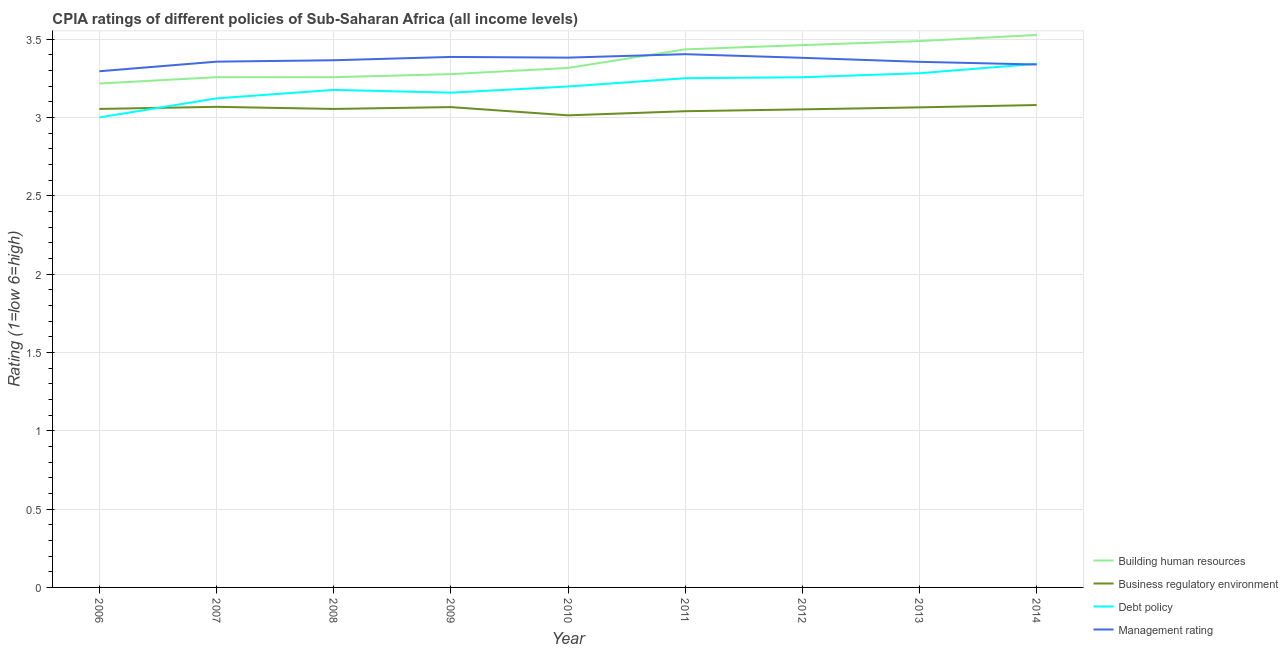Does the line corresponding to cpia rating of business regulatory environment intersect with the line corresponding to cpia rating of building human resources?
Ensure brevity in your answer.  No. Is the number of lines equal to the number of legend labels?
Your response must be concise. Yes. What is the cpia rating of management in 2010?
Provide a short and direct response. 3.38. Across all years, what is the maximum cpia rating of management?
Your answer should be compact. 3.4. Across all years, what is the minimum cpia rating of management?
Ensure brevity in your answer.  3.29. In which year was the cpia rating of management maximum?
Ensure brevity in your answer.  2011. What is the total cpia rating of business regulatory environment in the graph?
Make the answer very short. 27.49. What is the difference between the cpia rating of building human resources in 2010 and that in 2012?
Make the answer very short. -0.15. What is the difference between the cpia rating of business regulatory environment in 2006 and the cpia rating of debt policy in 2013?
Provide a short and direct response. -0.23. What is the average cpia rating of business regulatory environment per year?
Make the answer very short. 3.05. In the year 2010, what is the difference between the cpia rating of building human resources and cpia rating of business regulatory environment?
Offer a terse response. 0.3. What is the ratio of the cpia rating of management in 2012 to that in 2014?
Offer a very short reply. 1.01. What is the difference between the highest and the second highest cpia rating of business regulatory environment?
Make the answer very short. 0.01. What is the difference between the highest and the lowest cpia rating of building human resources?
Make the answer very short. 0.31. In how many years, is the cpia rating of building human resources greater than the average cpia rating of building human resources taken over all years?
Give a very brief answer. 4. Is it the case that in every year, the sum of the cpia rating of building human resources and cpia rating of business regulatory environment is greater than the cpia rating of debt policy?
Offer a terse response. Yes. Does the cpia rating of business regulatory environment monotonically increase over the years?
Make the answer very short. No. Is the cpia rating of building human resources strictly less than the cpia rating of management over the years?
Give a very brief answer. No. How many years are there in the graph?
Your answer should be very brief. 9. What is the difference between two consecutive major ticks on the Y-axis?
Your response must be concise. 0.5. Are the values on the major ticks of Y-axis written in scientific E-notation?
Offer a terse response. No. Does the graph contain any zero values?
Your response must be concise. No. Where does the legend appear in the graph?
Your answer should be compact. Bottom right. How many legend labels are there?
Offer a very short reply. 4. How are the legend labels stacked?
Provide a short and direct response. Vertical. What is the title of the graph?
Provide a succinct answer. CPIA ratings of different policies of Sub-Saharan Africa (all income levels). Does "UNDP" appear as one of the legend labels in the graph?
Your response must be concise. No. What is the Rating (1=low 6=high) in Building human resources in 2006?
Give a very brief answer. 3.22. What is the Rating (1=low 6=high) in Business regulatory environment in 2006?
Provide a succinct answer. 3.05. What is the Rating (1=low 6=high) in Debt policy in 2006?
Provide a short and direct response. 3. What is the Rating (1=low 6=high) of Management rating in 2006?
Make the answer very short. 3.29. What is the Rating (1=low 6=high) of Building human resources in 2007?
Your answer should be compact. 3.26. What is the Rating (1=low 6=high) in Business regulatory environment in 2007?
Your response must be concise. 3.07. What is the Rating (1=low 6=high) of Debt policy in 2007?
Provide a short and direct response. 3.12. What is the Rating (1=low 6=high) of Management rating in 2007?
Provide a succinct answer. 3.36. What is the Rating (1=low 6=high) of Building human resources in 2008?
Keep it short and to the point. 3.26. What is the Rating (1=low 6=high) in Business regulatory environment in 2008?
Ensure brevity in your answer.  3.05. What is the Rating (1=low 6=high) in Debt policy in 2008?
Make the answer very short. 3.18. What is the Rating (1=low 6=high) of Management rating in 2008?
Keep it short and to the point. 3.36. What is the Rating (1=low 6=high) of Building human resources in 2009?
Your answer should be compact. 3.28. What is the Rating (1=low 6=high) in Business regulatory environment in 2009?
Ensure brevity in your answer.  3.07. What is the Rating (1=low 6=high) in Debt policy in 2009?
Ensure brevity in your answer.  3.16. What is the Rating (1=low 6=high) of Management rating in 2009?
Your response must be concise. 3.39. What is the Rating (1=low 6=high) in Building human resources in 2010?
Your answer should be compact. 3.32. What is the Rating (1=low 6=high) of Business regulatory environment in 2010?
Offer a terse response. 3.01. What is the Rating (1=low 6=high) of Debt policy in 2010?
Keep it short and to the point. 3.2. What is the Rating (1=low 6=high) of Management rating in 2010?
Ensure brevity in your answer.  3.38. What is the Rating (1=low 6=high) in Building human resources in 2011?
Provide a short and direct response. 3.43. What is the Rating (1=low 6=high) of Business regulatory environment in 2011?
Your answer should be compact. 3.04. What is the Rating (1=low 6=high) in Management rating in 2011?
Ensure brevity in your answer.  3.4. What is the Rating (1=low 6=high) of Building human resources in 2012?
Provide a short and direct response. 3.46. What is the Rating (1=low 6=high) of Business regulatory environment in 2012?
Your answer should be compact. 3.05. What is the Rating (1=low 6=high) of Debt policy in 2012?
Your answer should be compact. 3.26. What is the Rating (1=low 6=high) in Management rating in 2012?
Ensure brevity in your answer.  3.38. What is the Rating (1=low 6=high) of Building human resources in 2013?
Provide a short and direct response. 3.49. What is the Rating (1=low 6=high) of Business regulatory environment in 2013?
Keep it short and to the point. 3.06. What is the Rating (1=low 6=high) in Debt policy in 2013?
Offer a very short reply. 3.28. What is the Rating (1=low 6=high) of Management rating in 2013?
Make the answer very short. 3.35. What is the Rating (1=low 6=high) of Building human resources in 2014?
Your answer should be very brief. 3.53. What is the Rating (1=low 6=high) of Business regulatory environment in 2014?
Your answer should be very brief. 3.08. What is the Rating (1=low 6=high) of Debt policy in 2014?
Give a very brief answer. 3.34. What is the Rating (1=low 6=high) in Management rating in 2014?
Provide a short and direct response. 3.34. Across all years, what is the maximum Rating (1=low 6=high) of Building human resources?
Offer a very short reply. 3.53. Across all years, what is the maximum Rating (1=low 6=high) in Business regulatory environment?
Make the answer very short. 3.08. Across all years, what is the maximum Rating (1=low 6=high) of Debt policy?
Give a very brief answer. 3.34. Across all years, what is the maximum Rating (1=low 6=high) of Management rating?
Your response must be concise. 3.4. Across all years, what is the minimum Rating (1=low 6=high) of Building human resources?
Make the answer very short. 3.22. Across all years, what is the minimum Rating (1=low 6=high) of Business regulatory environment?
Provide a short and direct response. 3.01. Across all years, what is the minimum Rating (1=low 6=high) in Debt policy?
Provide a short and direct response. 3. Across all years, what is the minimum Rating (1=low 6=high) of Management rating?
Your answer should be very brief. 3.29. What is the total Rating (1=low 6=high) of Building human resources in the graph?
Keep it short and to the point. 30.23. What is the total Rating (1=low 6=high) of Business regulatory environment in the graph?
Your response must be concise. 27.49. What is the total Rating (1=low 6=high) of Debt policy in the graph?
Make the answer very short. 28.78. What is the total Rating (1=low 6=high) of Management rating in the graph?
Your answer should be compact. 30.26. What is the difference between the Rating (1=low 6=high) of Building human resources in 2006 and that in 2007?
Give a very brief answer. -0.04. What is the difference between the Rating (1=low 6=high) of Business regulatory environment in 2006 and that in 2007?
Offer a very short reply. -0.01. What is the difference between the Rating (1=low 6=high) of Debt policy in 2006 and that in 2007?
Your response must be concise. -0.12. What is the difference between the Rating (1=low 6=high) of Management rating in 2006 and that in 2007?
Your response must be concise. -0.06. What is the difference between the Rating (1=low 6=high) in Building human resources in 2006 and that in 2008?
Give a very brief answer. -0.04. What is the difference between the Rating (1=low 6=high) of Debt policy in 2006 and that in 2008?
Make the answer very short. -0.18. What is the difference between the Rating (1=low 6=high) of Management rating in 2006 and that in 2008?
Offer a very short reply. -0.07. What is the difference between the Rating (1=low 6=high) in Building human resources in 2006 and that in 2009?
Give a very brief answer. -0.06. What is the difference between the Rating (1=low 6=high) of Business regulatory environment in 2006 and that in 2009?
Offer a terse response. -0.01. What is the difference between the Rating (1=low 6=high) of Debt policy in 2006 and that in 2009?
Provide a succinct answer. -0.16. What is the difference between the Rating (1=low 6=high) in Management rating in 2006 and that in 2009?
Make the answer very short. -0.09. What is the difference between the Rating (1=low 6=high) in Building human resources in 2006 and that in 2010?
Make the answer very short. -0.1. What is the difference between the Rating (1=low 6=high) of Business regulatory environment in 2006 and that in 2010?
Make the answer very short. 0.04. What is the difference between the Rating (1=low 6=high) of Debt policy in 2006 and that in 2010?
Offer a terse response. -0.2. What is the difference between the Rating (1=low 6=high) of Management rating in 2006 and that in 2010?
Give a very brief answer. -0.09. What is the difference between the Rating (1=low 6=high) in Building human resources in 2006 and that in 2011?
Make the answer very short. -0.22. What is the difference between the Rating (1=low 6=high) of Business regulatory environment in 2006 and that in 2011?
Provide a succinct answer. 0.01. What is the difference between the Rating (1=low 6=high) in Management rating in 2006 and that in 2011?
Your answer should be very brief. -0.11. What is the difference between the Rating (1=low 6=high) of Building human resources in 2006 and that in 2012?
Provide a succinct answer. -0.25. What is the difference between the Rating (1=low 6=high) of Business regulatory environment in 2006 and that in 2012?
Keep it short and to the point. 0. What is the difference between the Rating (1=low 6=high) of Debt policy in 2006 and that in 2012?
Offer a terse response. -0.26. What is the difference between the Rating (1=low 6=high) of Management rating in 2006 and that in 2012?
Keep it short and to the point. -0.09. What is the difference between the Rating (1=low 6=high) in Building human resources in 2006 and that in 2013?
Make the answer very short. -0.27. What is the difference between the Rating (1=low 6=high) in Business regulatory environment in 2006 and that in 2013?
Make the answer very short. -0.01. What is the difference between the Rating (1=low 6=high) of Debt policy in 2006 and that in 2013?
Offer a terse response. -0.28. What is the difference between the Rating (1=low 6=high) of Management rating in 2006 and that in 2013?
Give a very brief answer. -0.06. What is the difference between the Rating (1=low 6=high) in Building human resources in 2006 and that in 2014?
Ensure brevity in your answer.  -0.31. What is the difference between the Rating (1=low 6=high) in Business regulatory environment in 2006 and that in 2014?
Offer a very short reply. -0.02. What is the difference between the Rating (1=low 6=high) of Debt policy in 2006 and that in 2014?
Your answer should be very brief. -0.34. What is the difference between the Rating (1=low 6=high) of Management rating in 2006 and that in 2014?
Offer a terse response. -0.04. What is the difference between the Rating (1=low 6=high) of Building human resources in 2007 and that in 2008?
Provide a short and direct response. 0. What is the difference between the Rating (1=low 6=high) of Business regulatory environment in 2007 and that in 2008?
Offer a terse response. 0.01. What is the difference between the Rating (1=low 6=high) of Debt policy in 2007 and that in 2008?
Keep it short and to the point. -0.05. What is the difference between the Rating (1=low 6=high) of Management rating in 2007 and that in 2008?
Offer a terse response. -0.01. What is the difference between the Rating (1=low 6=high) of Building human resources in 2007 and that in 2009?
Your answer should be very brief. -0.02. What is the difference between the Rating (1=low 6=high) in Business regulatory environment in 2007 and that in 2009?
Offer a terse response. 0. What is the difference between the Rating (1=low 6=high) in Debt policy in 2007 and that in 2009?
Provide a short and direct response. -0.04. What is the difference between the Rating (1=low 6=high) of Management rating in 2007 and that in 2009?
Give a very brief answer. -0.03. What is the difference between the Rating (1=low 6=high) of Building human resources in 2007 and that in 2010?
Make the answer very short. -0.06. What is the difference between the Rating (1=low 6=high) of Business regulatory environment in 2007 and that in 2010?
Provide a succinct answer. 0.05. What is the difference between the Rating (1=low 6=high) of Debt policy in 2007 and that in 2010?
Your response must be concise. -0.08. What is the difference between the Rating (1=low 6=high) in Management rating in 2007 and that in 2010?
Give a very brief answer. -0.03. What is the difference between the Rating (1=low 6=high) of Building human resources in 2007 and that in 2011?
Provide a short and direct response. -0.18. What is the difference between the Rating (1=low 6=high) of Business regulatory environment in 2007 and that in 2011?
Keep it short and to the point. 0.03. What is the difference between the Rating (1=low 6=high) of Debt policy in 2007 and that in 2011?
Provide a succinct answer. -0.13. What is the difference between the Rating (1=low 6=high) in Management rating in 2007 and that in 2011?
Your response must be concise. -0.05. What is the difference between the Rating (1=low 6=high) of Building human resources in 2007 and that in 2012?
Provide a succinct answer. -0.2. What is the difference between the Rating (1=low 6=high) of Business regulatory environment in 2007 and that in 2012?
Your response must be concise. 0.02. What is the difference between the Rating (1=low 6=high) of Debt policy in 2007 and that in 2012?
Offer a terse response. -0.13. What is the difference between the Rating (1=low 6=high) of Management rating in 2007 and that in 2012?
Offer a terse response. -0.02. What is the difference between the Rating (1=low 6=high) of Building human resources in 2007 and that in 2013?
Give a very brief answer. -0.23. What is the difference between the Rating (1=low 6=high) in Business regulatory environment in 2007 and that in 2013?
Provide a short and direct response. 0. What is the difference between the Rating (1=low 6=high) of Debt policy in 2007 and that in 2013?
Keep it short and to the point. -0.16. What is the difference between the Rating (1=low 6=high) in Management rating in 2007 and that in 2013?
Your answer should be very brief. 0. What is the difference between the Rating (1=low 6=high) in Building human resources in 2007 and that in 2014?
Ensure brevity in your answer.  -0.27. What is the difference between the Rating (1=low 6=high) of Business regulatory environment in 2007 and that in 2014?
Provide a succinct answer. -0.01. What is the difference between the Rating (1=low 6=high) in Debt policy in 2007 and that in 2014?
Your answer should be compact. -0.22. What is the difference between the Rating (1=low 6=high) in Management rating in 2007 and that in 2014?
Give a very brief answer. 0.02. What is the difference between the Rating (1=low 6=high) of Building human resources in 2008 and that in 2009?
Ensure brevity in your answer.  -0.02. What is the difference between the Rating (1=low 6=high) of Business regulatory environment in 2008 and that in 2009?
Provide a short and direct response. -0.01. What is the difference between the Rating (1=low 6=high) of Debt policy in 2008 and that in 2009?
Ensure brevity in your answer.  0.02. What is the difference between the Rating (1=low 6=high) of Management rating in 2008 and that in 2009?
Provide a succinct answer. -0.02. What is the difference between the Rating (1=low 6=high) in Building human resources in 2008 and that in 2010?
Provide a succinct answer. -0.06. What is the difference between the Rating (1=low 6=high) in Business regulatory environment in 2008 and that in 2010?
Offer a terse response. 0.04. What is the difference between the Rating (1=low 6=high) of Debt policy in 2008 and that in 2010?
Offer a very short reply. -0.02. What is the difference between the Rating (1=low 6=high) in Management rating in 2008 and that in 2010?
Provide a short and direct response. -0.02. What is the difference between the Rating (1=low 6=high) of Building human resources in 2008 and that in 2011?
Make the answer very short. -0.18. What is the difference between the Rating (1=low 6=high) of Business regulatory environment in 2008 and that in 2011?
Provide a short and direct response. 0.01. What is the difference between the Rating (1=low 6=high) in Debt policy in 2008 and that in 2011?
Your response must be concise. -0.07. What is the difference between the Rating (1=low 6=high) of Management rating in 2008 and that in 2011?
Give a very brief answer. -0.04. What is the difference between the Rating (1=low 6=high) of Building human resources in 2008 and that in 2012?
Offer a very short reply. -0.2. What is the difference between the Rating (1=low 6=high) of Business regulatory environment in 2008 and that in 2012?
Offer a very short reply. 0. What is the difference between the Rating (1=low 6=high) in Debt policy in 2008 and that in 2012?
Your answer should be very brief. -0.08. What is the difference between the Rating (1=low 6=high) of Management rating in 2008 and that in 2012?
Provide a succinct answer. -0.02. What is the difference between the Rating (1=low 6=high) in Building human resources in 2008 and that in 2013?
Your answer should be very brief. -0.23. What is the difference between the Rating (1=low 6=high) of Business regulatory environment in 2008 and that in 2013?
Make the answer very short. -0.01. What is the difference between the Rating (1=low 6=high) in Debt policy in 2008 and that in 2013?
Offer a very short reply. -0.11. What is the difference between the Rating (1=low 6=high) of Management rating in 2008 and that in 2013?
Give a very brief answer. 0.01. What is the difference between the Rating (1=low 6=high) in Building human resources in 2008 and that in 2014?
Ensure brevity in your answer.  -0.27. What is the difference between the Rating (1=low 6=high) of Business regulatory environment in 2008 and that in 2014?
Ensure brevity in your answer.  -0.02. What is the difference between the Rating (1=low 6=high) in Debt policy in 2008 and that in 2014?
Offer a terse response. -0.17. What is the difference between the Rating (1=low 6=high) in Management rating in 2008 and that in 2014?
Keep it short and to the point. 0.03. What is the difference between the Rating (1=low 6=high) of Building human resources in 2009 and that in 2010?
Your answer should be compact. -0.04. What is the difference between the Rating (1=low 6=high) of Business regulatory environment in 2009 and that in 2010?
Your answer should be very brief. 0.05. What is the difference between the Rating (1=low 6=high) of Debt policy in 2009 and that in 2010?
Ensure brevity in your answer.  -0.04. What is the difference between the Rating (1=low 6=high) of Management rating in 2009 and that in 2010?
Your response must be concise. 0. What is the difference between the Rating (1=low 6=high) in Building human resources in 2009 and that in 2011?
Ensure brevity in your answer.  -0.16. What is the difference between the Rating (1=low 6=high) in Business regulatory environment in 2009 and that in 2011?
Provide a short and direct response. 0.03. What is the difference between the Rating (1=low 6=high) in Debt policy in 2009 and that in 2011?
Ensure brevity in your answer.  -0.09. What is the difference between the Rating (1=low 6=high) in Management rating in 2009 and that in 2011?
Provide a succinct answer. -0.02. What is the difference between the Rating (1=low 6=high) in Building human resources in 2009 and that in 2012?
Your answer should be compact. -0.19. What is the difference between the Rating (1=low 6=high) in Business regulatory environment in 2009 and that in 2012?
Give a very brief answer. 0.01. What is the difference between the Rating (1=low 6=high) in Debt policy in 2009 and that in 2012?
Offer a terse response. -0.1. What is the difference between the Rating (1=low 6=high) of Management rating in 2009 and that in 2012?
Offer a very short reply. 0.01. What is the difference between the Rating (1=low 6=high) in Building human resources in 2009 and that in 2013?
Your answer should be compact. -0.21. What is the difference between the Rating (1=low 6=high) in Business regulatory environment in 2009 and that in 2013?
Offer a very short reply. 0. What is the difference between the Rating (1=low 6=high) of Debt policy in 2009 and that in 2013?
Offer a terse response. -0.12. What is the difference between the Rating (1=low 6=high) in Management rating in 2009 and that in 2013?
Provide a short and direct response. 0.03. What is the difference between the Rating (1=low 6=high) of Business regulatory environment in 2009 and that in 2014?
Ensure brevity in your answer.  -0.01. What is the difference between the Rating (1=low 6=high) of Debt policy in 2009 and that in 2014?
Give a very brief answer. -0.18. What is the difference between the Rating (1=low 6=high) of Management rating in 2009 and that in 2014?
Provide a succinct answer. 0.05. What is the difference between the Rating (1=low 6=high) of Building human resources in 2010 and that in 2011?
Provide a succinct answer. -0.12. What is the difference between the Rating (1=low 6=high) of Business regulatory environment in 2010 and that in 2011?
Your answer should be very brief. -0.03. What is the difference between the Rating (1=low 6=high) in Debt policy in 2010 and that in 2011?
Ensure brevity in your answer.  -0.05. What is the difference between the Rating (1=low 6=high) of Management rating in 2010 and that in 2011?
Offer a terse response. -0.02. What is the difference between the Rating (1=low 6=high) in Building human resources in 2010 and that in 2012?
Keep it short and to the point. -0.15. What is the difference between the Rating (1=low 6=high) of Business regulatory environment in 2010 and that in 2012?
Offer a very short reply. -0.04. What is the difference between the Rating (1=low 6=high) in Debt policy in 2010 and that in 2012?
Keep it short and to the point. -0.06. What is the difference between the Rating (1=low 6=high) of Management rating in 2010 and that in 2012?
Give a very brief answer. 0. What is the difference between the Rating (1=low 6=high) of Building human resources in 2010 and that in 2013?
Offer a terse response. -0.17. What is the difference between the Rating (1=low 6=high) in Business regulatory environment in 2010 and that in 2013?
Give a very brief answer. -0.05. What is the difference between the Rating (1=low 6=high) of Debt policy in 2010 and that in 2013?
Your answer should be compact. -0.08. What is the difference between the Rating (1=low 6=high) in Management rating in 2010 and that in 2013?
Provide a succinct answer. 0.03. What is the difference between the Rating (1=low 6=high) in Building human resources in 2010 and that in 2014?
Provide a succinct answer. -0.21. What is the difference between the Rating (1=low 6=high) of Business regulatory environment in 2010 and that in 2014?
Your answer should be very brief. -0.07. What is the difference between the Rating (1=low 6=high) in Debt policy in 2010 and that in 2014?
Offer a very short reply. -0.14. What is the difference between the Rating (1=low 6=high) of Management rating in 2010 and that in 2014?
Give a very brief answer. 0.04. What is the difference between the Rating (1=low 6=high) of Building human resources in 2011 and that in 2012?
Give a very brief answer. -0.03. What is the difference between the Rating (1=low 6=high) in Business regulatory environment in 2011 and that in 2012?
Ensure brevity in your answer.  -0.01. What is the difference between the Rating (1=low 6=high) of Debt policy in 2011 and that in 2012?
Your answer should be very brief. -0.01. What is the difference between the Rating (1=low 6=high) of Management rating in 2011 and that in 2012?
Your answer should be very brief. 0.02. What is the difference between the Rating (1=low 6=high) in Building human resources in 2011 and that in 2013?
Offer a very short reply. -0.05. What is the difference between the Rating (1=low 6=high) of Business regulatory environment in 2011 and that in 2013?
Ensure brevity in your answer.  -0.02. What is the difference between the Rating (1=low 6=high) of Debt policy in 2011 and that in 2013?
Offer a terse response. -0.03. What is the difference between the Rating (1=low 6=high) of Management rating in 2011 and that in 2013?
Make the answer very short. 0.05. What is the difference between the Rating (1=low 6=high) in Building human resources in 2011 and that in 2014?
Offer a terse response. -0.09. What is the difference between the Rating (1=low 6=high) of Business regulatory environment in 2011 and that in 2014?
Provide a succinct answer. -0.04. What is the difference between the Rating (1=low 6=high) of Debt policy in 2011 and that in 2014?
Give a very brief answer. -0.09. What is the difference between the Rating (1=low 6=high) in Management rating in 2011 and that in 2014?
Your response must be concise. 0.07. What is the difference between the Rating (1=low 6=high) in Building human resources in 2012 and that in 2013?
Your answer should be very brief. -0.03. What is the difference between the Rating (1=low 6=high) of Business regulatory environment in 2012 and that in 2013?
Offer a very short reply. -0.01. What is the difference between the Rating (1=low 6=high) of Debt policy in 2012 and that in 2013?
Keep it short and to the point. -0.03. What is the difference between the Rating (1=low 6=high) of Management rating in 2012 and that in 2013?
Offer a terse response. 0.03. What is the difference between the Rating (1=low 6=high) of Building human resources in 2012 and that in 2014?
Provide a short and direct response. -0.06. What is the difference between the Rating (1=low 6=high) in Business regulatory environment in 2012 and that in 2014?
Provide a succinct answer. -0.03. What is the difference between the Rating (1=low 6=high) in Debt policy in 2012 and that in 2014?
Keep it short and to the point. -0.09. What is the difference between the Rating (1=low 6=high) of Management rating in 2012 and that in 2014?
Your answer should be very brief. 0.04. What is the difference between the Rating (1=low 6=high) of Building human resources in 2013 and that in 2014?
Give a very brief answer. -0.04. What is the difference between the Rating (1=low 6=high) of Business regulatory environment in 2013 and that in 2014?
Your response must be concise. -0.01. What is the difference between the Rating (1=low 6=high) in Debt policy in 2013 and that in 2014?
Provide a short and direct response. -0.06. What is the difference between the Rating (1=low 6=high) in Management rating in 2013 and that in 2014?
Your answer should be very brief. 0.02. What is the difference between the Rating (1=low 6=high) in Building human resources in 2006 and the Rating (1=low 6=high) in Business regulatory environment in 2007?
Provide a short and direct response. 0.15. What is the difference between the Rating (1=low 6=high) in Building human resources in 2006 and the Rating (1=low 6=high) in Debt policy in 2007?
Keep it short and to the point. 0.09. What is the difference between the Rating (1=low 6=high) of Building human resources in 2006 and the Rating (1=low 6=high) of Management rating in 2007?
Provide a succinct answer. -0.14. What is the difference between the Rating (1=low 6=high) in Business regulatory environment in 2006 and the Rating (1=low 6=high) in Debt policy in 2007?
Your response must be concise. -0.07. What is the difference between the Rating (1=low 6=high) of Business regulatory environment in 2006 and the Rating (1=low 6=high) of Management rating in 2007?
Ensure brevity in your answer.  -0.3. What is the difference between the Rating (1=low 6=high) of Debt policy in 2006 and the Rating (1=low 6=high) of Management rating in 2007?
Keep it short and to the point. -0.36. What is the difference between the Rating (1=low 6=high) of Building human resources in 2006 and the Rating (1=low 6=high) of Business regulatory environment in 2008?
Offer a terse response. 0.16. What is the difference between the Rating (1=low 6=high) in Building human resources in 2006 and the Rating (1=low 6=high) in Debt policy in 2008?
Your answer should be very brief. 0.04. What is the difference between the Rating (1=low 6=high) of Building human resources in 2006 and the Rating (1=low 6=high) of Management rating in 2008?
Your answer should be compact. -0.15. What is the difference between the Rating (1=low 6=high) of Business regulatory environment in 2006 and the Rating (1=low 6=high) of Debt policy in 2008?
Keep it short and to the point. -0.12. What is the difference between the Rating (1=low 6=high) of Business regulatory environment in 2006 and the Rating (1=low 6=high) of Management rating in 2008?
Keep it short and to the point. -0.31. What is the difference between the Rating (1=low 6=high) of Debt policy in 2006 and the Rating (1=low 6=high) of Management rating in 2008?
Provide a succinct answer. -0.36. What is the difference between the Rating (1=low 6=high) in Building human resources in 2006 and the Rating (1=low 6=high) in Business regulatory environment in 2009?
Keep it short and to the point. 0.15. What is the difference between the Rating (1=low 6=high) in Building human resources in 2006 and the Rating (1=low 6=high) in Debt policy in 2009?
Your answer should be very brief. 0.06. What is the difference between the Rating (1=low 6=high) of Building human resources in 2006 and the Rating (1=low 6=high) of Management rating in 2009?
Provide a succinct answer. -0.17. What is the difference between the Rating (1=low 6=high) in Business regulatory environment in 2006 and the Rating (1=low 6=high) in Debt policy in 2009?
Provide a succinct answer. -0.1. What is the difference between the Rating (1=low 6=high) in Business regulatory environment in 2006 and the Rating (1=low 6=high) in Management rating in 2009?
Give a very brief answer. -0.33. What is the difference between the Rating (1=low 6=high) of Debt policy in 2006 and the Rating (1=low 6=high) of Management rating in 2009?
Give a very brief answer. -0.39. What is the difference between the Rating (1=low 6=high) in Building human resources in 2006 and the Rating (1=low 6=high) in Business regulatory environment in 2010?
Your answer should be very brief. 0.2. What is the difference between the Rating (1=low 6=high) of Building human resources in 2006 and the Rating (1=low 6=high) of Debt policy in 2010?
Your answer should be very brief. 0.02. What is the difference between the Rating (1=low 6=high) of Building human resources in 2006 and the Rating (1=low 6=high) of Management rating in 2010?
Provide a succinct answer. -0.17. What is the difference between the Rating (1=low 6=high) in Business regulatory environment in 2006 and the Rating (1=low 6=high) in Debt policy in 2010?
Ensure brevity in your answer.  -0.14. What is the difference between the Rating (1=low 6=high) of Business regulatory environment in 2006 and the Rating (1=low 6=high) of Management rating in 2010?
Offer a very short reply. -0.33. What is the difference between the Rating (1=low 6=high) in Debt policy in 2006 and the Rating (1=low 6=high) in Management rating in 2010?
Give a very brief answer. -0.38. What is the difference between the Rating (1=low 6=high) in Building human resources in 2006 and the Rating (1=low 6=high) in Business regulatory environment in 2011?
Provide a succinct answer. 0.18. What is the difference between the Rating (1=low 6=high) of Building human resources in 2006 and the Rating (1=low 6=high) of Debt policy in 2011?
Provide a succinct answer. -0.03. What is the difference between the Rating (1=low 6=high) in Building human resources in 2006 and the Rating (1=low 6=high) in Management rating in 2011?
Your answer should be compact. -0.19. What is the difference between the Rating (1=low 6=high) in Business regulatory environment in 2006 and the Rating (1=low 6=high) in Debt policy in 2011?
Provide a short and direct response. -0.2. What is the difference between the Rating (1=low 6=high) of Business regulatory environment in 2006 and the Rating (1=low 6=high) of Management rating in 2011?
Keep it short and to the point. -0.35. What is the difference between the Rating (1=low 6=high) in Debt policy in 2006 and the Rating (1=low 6=high) in Management rating in 2011?
Make the answer very short. -0.4. What is the difference between the Rating (1=low 6=high) in Building human resources in 2006 and the Rating (1=low 6=high) in Business regulatory environment in 2012?
Your answer should be compact. 0.16. What is the difference between the Rating (1=low 6=high) in Building human resources in 2006 and the Rating (1=low 6=high) in Debt policy in 2012?
Offer a very short reply. -0.04. What is the difference between the Rating (1=low 6=high) in Building human resources in 2006 and the Rating (1=low 6=high) in Management rating in 2012?
Provide a short and direct response. -0.16. What is the difference between the Rating (1=low 6=high) of Business regulatory environment in 2006 and the Rating (1=low 6=high) of Debt policy in 2012?
Give a very brief answer. -0.2. What is the difference between the Rating (1=low 6=high) of Business regulatory environment in 2006 and the Rating (1=low 6=high) of Management rating in 2012?
Your response must be concise. -0.33. What is the difference between the Rating (1=low 6=high) of Debt policy in 2006 and the Rating (1=low 6=high) of Management rating in 2012?
Ensure brevity in your answer.  -0.38. What is the difference between the Rating (1=low 6=high) in Building human resources in 2006 and the Rating (1=low 6=high) in Business regulatory environment in 2013?
Provide a succinct answer. 0.15. What is the difference between the Rating (1=low 6=high) of Building human resources in 2006 and the Rating (1=low 6=high) of Debt policy in 2013?
Provide a succinct answer. -0.07. What is the difference between the Rating (1=low 6=high) of Building human resources in 2006 and the Rating (1=low 6=high) of Management rating in 2013?
Give a very brief answer. -0.14. What is the difference between the Rating (1=low 6=high) in Business regulatory environment in 2006 and the Rating (1=low 6=high) in Debt policy in 2013?
Your answer should be very brief. -0.23. What is the difference between the Rating (1=low 6=high) in Business regulatory environment in 2006 and the Rating (1=low 6=high) in Management rating in 2013?
Provide a short and direct response. -0.3. What is the difference between the Rating (1=low 6=high) in Debt policy in 2006 and the Rating (1=low 6=high) in Management rating in 2013?
Offer a very short reply. -0.35. What is the difference between the Rating (1=low 6=high) in Building human resources in 2006 and the Rating (1=low 6=high) in Business regulatory environment in 2014?
Your response must be concise. 0.14. What is the difference between the Rating (1=low 6=high) of Building human resources in 2006 and the Rating (1=low 6=high) of Debt policy in 2014?
Give a very brief answer. -0.13. What is the difference between the Rating (1=low 6=high) in Building human resources in 2006 and the Rating (1=low 6=high) in Management rating in 2014?
Give a very brief answer. -0.12. What is the difference between the Rating (1=low 6=high) in Business regulatory environment in 2006 and the Rating (1=low 6=high) in Debt policy in 2014?
Your response must be concise. -0.29. What is the difference between the Rating (1=low 6=high) of Business regulatory environment in 2006 and the Rating (1=low 6=high) of Management rating in 2014?
Offer a very short reply. -0.28. What is the difference between the Rating (1=low 6=high) of Debt policy in 2006 and the Rating (1=low 6=high) of Management rating in 2014?
Your answer should be very brief. -0.34. What is the difference between the Rating (1=low 6=high) in Building human resources in 2007 and the Rating (1=low 6=high) in Business regulatory environment in 2008?
Your response must be concise. 0.2. What is the difference between the Rating (1=low 6=high) in Building human resources in 2007 and the Rating (1=low 6=high) in Debt policy in 2008?
Your response must be concise. 0.08. What is the difference between the Rating (1=low 6=high) in Building human resources in 2007 and the Rating (1=low 6=high) in Management rating in 2008?
Give a very brief answer. -0.11. What is the difference between the Rating (1=low 6=high) in Business regulatory environment in 2007 and the Rating (1=low 6=high) in Debt policy in 2008?
Your response must be concise. -0.11. What is the difference between the Rating (1=low 6=high) of Business regulatory environment in 2007 and the Rating (1=low 6=high) of Management rating in 2008?
Your answer should be very brief. -0.3. What is the difference between the Rating (1=low 6=high) in Debt policy in 2007 and the Rating (1=low 6=high) in Management rating in 2008?
Offer a very short reply. -0.24. What is the difference between the Rating (1=low 6=high) in Building human resources in 2007 and the Rating (1=low 6=high) in Business regulatory environment in 2009?
Your answer should be very brief. 0.19. What is the difference between the Rating (1=low 6=high) in Building human resources in 2007 and the Rating (1=low 6=high) in Debt policy in 2009?
Offer a terse response. 0.1. What is the difference between the Rating (1=low 6=high) of Building human resources in 2007 and the Rating (1=low 6=high) of Management rating in 2009?
Ensure brevity in your answer.  -0.13. What is the difference between the Rating (1=low 6=high) in Business regulatory environment in 2007 and the Rating (1=low 6=high) in Debt policy in 2009?
Your answer should be very brief. -0.09. What is the difference between the Rating (1=low 6=high) in Business regulatory environment in 2007 and the Rating (1=low 6=high) in Management rating in 2009?
Offer a very short reply. -0.32. What is the difference between the Rating (1=low 6=high) of Debt policy in 2007 and the Rating (1=low 6=high) of Management rating in 2009?
Keep it short and to the point. -0.26. What is the difference between the Rating (1=low 6=high) in Building human resources in 2007 and the Rating (1=low 6=high) in Business regulatory environment in 2010?
Offer a very short reply. 0.24. What is the difference between the Rating (1=low 6=high) of Building human resources in 2007 and the Rating (1=low 6=high) of Debt policy in 2010?
Your answer should be compact. 0.06. What is the difference between the Rating (1=low 6=high) in Building human resources in 2007 and the Rating (1=low 6=high) in Management rating in 2010?
Keep it short and to the point. -0.12. What is the difference between the Rating (1=low 6=high) in Business regulatory environment in 2007 and the Rating (1=low 6=high) in Debt policy in 2010?
Your response must be concise. -0.13. What is the difference between the Rating (1=low 6=high) in Business regulatory environment in 2007 and the Rating (1=low 6=high) in Management rating in 2010?
Keep it short and to the point. -0.31. What is the difference between the Rating (1=low 6=high) in Debt policy in 2007 and the Rating (1=low 6=high) in Management rating in 2010?
Your response must be concise. -0.26. What is the difference between the Rating (1=low 6=high) in Building human resources in 2007 and the Rating (1=low 6=high) in Business regulatory environment in 2011?
Your answer should be compact. 0.22. What is the difference between the Rating (1=low 6=high) in Building human resources in 2007 and the Rating (1=low 6=high) in Debt policy in 2011?
Offer a terse response. 0.01. What is the difference between the Rating (1=low 6=high) of Building human resources in 2007 and the Rating (1=low 6=high) of Management rating in 2011?
Offer a terse response. -0.15. What is the difference between the Rating (1=low 6=high) in Business regulatory environment in 2007 and the Rating (1=low 6=high) in Debt policy in 2011?
Provide a succinct answer. -0.18. What is the difference between the Rating (1=low 6=high) of Business regulatory environment in 2007 and the Rating (1=low 6=high) of Management rating in 2011?
Keep it short and to the point. -0.34. What is the difference between the Rating (1=low 6=high) of Debt policy in 2007 and the Rating (1=low 6=high) of Management rating in 2011?
Keep it short and to the point. -0.28. What is the difference between the Rating (1=low 6=high) in Building human resources in 2007 and the Rating (1=low 6=high) in Business regulatory environment in 2012?
Offer a very short reply. 0.21. What is the difference between the Rating (1=low 6=high) in Building human resources in 2007 and the Rating (1=low 6=high) in Management rating in 2012?
Keep it short and to the point. -0.12. What is the difference between the Rating (1=low 6=high) of Business regulatory environment in 2007 and the Rating (1=low 6=high) of Debt policy in 2012?
Your response must be concise. -0.19. What is the difference between the Rating (1=low 6=high) in Business regulatory environment in 2007 and the Rating (1=low 6=high) in Management rating in 2012?
Provide a succinct answer. -0.31. What is the difference between the Rating (1=low 6=high) in Debt policy in 2007 and the Rating (1=low 6=high) in Management rating in 2012?
Give a very brief answer. -0.26. What is the difference between the Rating (1=low 6=high) in Building human resources in 2007 and the Rating (1=low 6=high) in Business regulatory environment in 2013?
Keep it short and to the point. 0.19. What is the difference between the Rating (1=low 6=high) in Building human resources in 2007 and the Rating (1=low 6=high) in Debt policy in 2013?
Make the answer very short. -0.03. What is the difference between the Rating (1=low 6=high) in Building human resources in 2007 and the Rating (1=low 6=high) in Management rating in 2013?
Your answer should be very brief. -0.1. What is the difference between the Rating (1=low 6=high) of Business regulatory environment in 2007 and the Rating (1=low 6=high) of Debt policy in 2013?
Make the answer very short. -0.21. What is the difference between the Rating (1=low 6=high) in Business regulatory environment in 2007 and the Rating (1=low 6=high) in Management rating in 2013?
Your answer should be compact. -0.29. What is the difference between the Rating (1=low 6=high) in Debt policy in 2007 and the Rating (1=low 6=high) in Management rating in 2013?
Provide a short and direct response. -0.23. What is the difference between the Rating (1=low 6=high) of Building human resources in 2007 and the Rating (1=low 6=high) of Business regulatory environment in 2014?
Your response must be concise. 0.18. What is the difference between the Rating (1=low 6=high) in Building human resources in 2007 and the Rating (1=low 6=high) in Debt policy in 2014?
Offer a terse response. -0.09. What is the difference between the Rating (1=low 6=high) in Building human resources in 2007 and the Rating (1=low 6=high) in Management rating in 2014?
Keep it short and to the point. -0.08. What is the difference between the Rating (1=low 6=high) in Business regulatory environment in 2007 and the Rating (1=low 6=high) in Debt policy in 2014?
Ensure brevity in your answer.  -0.27. What is the difference between the Rating (1=low 6=high) of Business regulatory environment in 2007 and the Rating (1=low 6=high) of Management rating in 2014?
Your response must be concise. -0.27. What is the difference between the Rating (1=low 6=high) in Debt policy in 2007 and the Rating (1=low 6=high) in Management rating in 2014?
Provide a succinct answer. -0.22. What is the difference between the Rating (1=low 6=high) of Building human resources in 2008 and the Rating (1=low 6=high) of Business regulatory environment in 2009?
Your answer should be compact. 0.19. What is the difference between the Rating (1=low 6=high) in Building human resources in 2008 and the Rating (1=low 6=high) in Debt policy in 2009?
Offer a terse response. 0.1. What is the difference between the Rating (1=low 6=high) in Building human resources in 2008 and the Rating (1=low 6=high) in Management rating in 2009?
Offer a terse response. -0.13. What is the difference between the Rating (1=low 6=high) in Business regulatory environment in 2008 and the Rating (1=low 6=high) in Debt policy in 2009?
Your response must be concise. -0.1. What is the difference between the Rating (1=low 6=high) in Business regulatory environment in 2008 and the Rating (1=low 6=high) in Management rating in 2009?
Your answer should be very brief. -0.33. What is the difference between the Rating (1=low 6=high) in Debt policy in 2008 and the Rating (1=low 6=high) in Management rating in 2009?
Ensure brevity in your answer.  -0.21. What is the difference between the Rating (1=low 6=high) in Building human resources in 2008 and the Rating (1=low 6=high) in Business regulatory environment in 2010?
Your response must be concise. 0.24. What is the difference between the Rating (1=low 6=high) of Building human resources in 2008 and the Rating (1=low 6=high) of Debt policy in 2010?
Make the answer very short. 0.06. What is the difference between the Rating (1=low 6=high) in Building human resources in 2008 and the Rating (1=low 6=high) in Management rating in 2010?
Give a very brief answer. -0.12. What is the difference between the Rating (1=low 6=high) in Business regulatory environment in 2008 and the Rating (1=low 6=high) in Debt policy in 2010?
Make the answer very short. -0.14. What is the difference between the Rating (1=low 6=high) of Business regulatory environment in 2008 and the Rating (1=low 6=high) of Management rating in 2010?
Your response must be concise. -0.33. What is the difference between the Rating (1=low 6=high) in Debt policy in 2008 and the Rating (1=low 6=high) in Management rating in 2010?
Provide a short and direct response. -0.21. What is the difference between the Rating (1=low 6=high) in Building human resources in 2008 and the Rating (1=low 6=high) in Business regulatory environment in 2011?
Offer a terse response. 0.22. What is the difference between the Rating (1=low 6=high) in Building human resources in 2008 and the Rating (1=low 6=high) in Debt policy in 2011?
Your answer should be very brief. 0.01. What is the difference between the Rating (1=low 6=high) of Building human resources in 2008 and the Rating (1=low 6=high) of Management rating in 2011?
Your answer should be very brief. -0.15. What is the difference between the Rating (1=low 6=high) of Business regulatory environment in 2008 and the Rating (1=low 6=high) of Debt policy in 2011?
Give a very brief answer. -0.2. What is the difference between the Rating (1=low 6=high) of Business regulatory environment in 2008 and the Rating (1=low 6=high) of Management rating in 2011?
Your answer should be compact. -0.35. What is the difference between the Rating (1=low 6=high) in Debt policy in 2008 and the Rating (1=low 6=high) in Management rating in 2011?
Your response must be concise. -0.23. What is the difference between the Rating (1=low 6=high) in Building human resources in 2008 and the Rating (1=low 6=high) in Business regulatory environment in 2012?
Offer a terse response. 0.21. What is the difference between the Rating (1=low 6=high) in Building human resources in 2008 and the Rating (1=low 6=high) in Debt policy in 2012?
Your response must be concise. 0. What is the difference between the Rating (1=low 6=high) of Building human resources in 2008 and the Rating (1=low 6=high) of Management rating in 2012?
Your answer should be compact. -0.12. What is the difference between the Rating (1=low 6=high) in Business regulatory environment in 2008 and the Rating (1=low 6=high) in Debt policy in 2012?
Your response must be concise. -0.2. What is the difference between the Rating (1=low 6=high) of Business regulatory environment in 2008 and the Rating (1=low 6=high) of Management rating in 2012?
Your answer should be compact. -0.33. What is the difference between the Rating (1=low 6=high) in Debt policy in 2008 and the Rating (1=low 6=high) in Management rating in 2012?
Provide a succinct answer. -0.2. What is the difference between the Rating (1=low 6=high) of Building human resources in 2008 and the Rating (1=low 6=high) of Business regulatory environment in 2013?
Your answer should be very brief. 0.19. What is the difference between the Rating (1=low 6=high) in Building human resources in 2008 and the Rating (1=low 6=high) in Debt policy in 2013?
Give a very brief answer. -0.03. What is the difference between the Rating (1=low 6=high) in Building human resources in 2008 and the Rating (1=low 6=high) in Management rating in 2013?
Make the answer very short. -0.1. What is the difference between the Rating (1=low 6=high) in Business regulatory environment in 2008 and the Rating (1=low 6=high) in Debt policy in 2013?
Your answer should be very brief. -0.23. What is the difference between the Rating (1=low 6=high) of Business regulatory environment in 2008 and the Rating (1=low 6=high) of Management rating in 2013?
Provide a succinct answer. -0.3. What is the difference between the Rating (1=low 6=high) in Debt policy in 2008 and the Rating (1=low 6=high) in Management rating in 2013?
Your response must be concise. -0.18. What is the difference between the Rating (1=low 6=high) in Building human resources in 2008 and the Rating (1=low 6=high) in Business regulatory environment in 2014?
Provide a short and direct response. 0.18. What is the difference between the Rating (1=low 6=high) of Building human resources in 2008 and the Rating (1=low 6=high) of Debt policy in 2014?
Ensure brevity in your answer.  -0.09. What is the difference between the Rating (1=low 6=high) of Building human resources in 2008 and the Rating (1=low 6=high) of Management rating in 2014?
Provide a succinct answer. -0.08. What is the difference between the Rating (1=low 6=high) in Business regulatory environment in 2008 and the Rating (1=low 6=high) in Debt policy in 2014?
Make the answer very short. -0.29. What is the difference between the Rating (1=low 6=high) of Business regulatory environment in 2008 and the Rating (1=low 6=high) of Management rating in 2014?
Give a very brief answer. -0.28. What is the difference between the Rating (1=low 6=high) of Debt policy in 2008 and the Rating (1=low 6=high) of Management rating in 2014?
Your answer should be very brief. -0.16. What is the difference between the Rating (1=low 6=high) of Building human resources in 2009 and the Rating (1=low 6=high) of Business regulatory environment in 2010?
Keep it short and to the point. 0.26. What is the difference between the Rating (1=low 6=high) in Building human resources in 2009 and the Rating (1=low 6=high) in Debt policy in 2010?
Offer a terse response. 0.08. What is the difference between the Rating (1=low 6=high) in Building human resources in 2009 and the Rating (1=low 6=high) in Management rating in 2010?
Make the answer very short. -0.11. What is the difference between the Rating (1=low 6=high) in Business regulatory environment in 2009 and the Rating (1=low 6=high) in Debt policy in 2010?
Offer a terse response. -0.13. What is the difference between the Rating (1=low 6=high) in Business regulatory environment in 2009 and the Rating (1=low 6=high) in Management rating in 2010?
Your response must be concise. -0.32. What is the difference between the Rating (1=low 6=high) of Debt policy in 2009 and the Rating (1=low 6=high) of Management rating in 2010?
Your response must be concise. -0.22. What is the difference between the Rating (1=low 6=high) of Building human resources in 2009 and the Rating (1=low 6=high) of Business regulatory environment in 2011?
Offer a terse response. 0.24. What is the difference between the Rating (1=low 6=high) in Building human resources in 2009 and the Rating (1=low 6=high) in Debt policy in 2011?
Offer a very short reply. 0.03. What is the difference between the Rating (1=low 6=high) in Building human resources in 2009 and the Rating (1=low 6=high) in Management rating in 2011?
Your answer should be very brief. -0.13. What is the difference between the Rating (1=low 6=high) in Business regulatory environment in 2009 and the Rating (1=low 6=high) in Debt policy in 2011?
Provide a short and direct response. -0.18. What is the difference between the Rating (1=low 6=high) in Business regulatory environment in 2009 and the Rating (1=low 6=high) in Management rating in 2011?
Provide a short and direct response. -0.34. What is the difference between the Rating (1=low 6=high) of Debt policy in 2009 and the Rating (1=low 6=high) of Management rating in 2011?
Offer a terse response. -0.25. What is the difference between the Rating (1=low 6=high) in Building human resources in 2009 and the Rating (1=low 6=high) in Business regulatory environment in 2012?
Provide a succinct answer. 0.23. What is the difference between the Rating (1=low 6=high) in Building human resources in 2009 and the Rating (1=low 6=high) in Debt policy in 2012?
Give a very brief answer. 0.02. What is the difference between the Rating (1=low 6=high) of Building human resources in 2009 and the Rating (1=low 6=high) of Management rating in 2012?
Ensure brevity in your answer.  -0.1. What is the difference between the Rating (1=low 6=high) of Business regulatory environment in 2009 and the Rating (1=low 6=high) of Debt policy in 2012?
Provide a short and direct response. -0.19. What is the difference between the Rating (1=low 6=high) in Business regulatory environment in 2009 and the Rating (1=low 6=high) in Management rating in 2012?
Offer a very short reply. -0.31. What is the difference between the Rating (1=low 6=high) in Debt policy in 2009 and the Rating (1=low 6=high) in Management rating in 2012?
Ensure brevity in your answer.  -0.22. What is the difference between the Rating (1=low 6=high) in Building human resources in 2009 and the Rating (1=low 6=high) in Business regulatory environment in 2013?
Offer a very short reply. 0.21. What is the difference between the Rating (1=low 6=high) of Building human resources in 2009 and the Rating (1=low 6=high) of Debt policy in 2013?
Give a very brief answer. -0.01. What is the difference between the Rating (1=low 6=high) of Building human resources in 2009 and the Rating (1=low 6=high) of Management rating in 2013?
Keep it short and to the point. -0.08. What is the difference between the Rating (1=low 6=high) of Business regulatory environment in 2009 and the Rating (1=low 6=high) of Debt policy in 2013?
Your answer should be very brief. -0.22. What is the difference between the Rating (1=low 6=high) in Business regulatory environment in 2009 and the Rating (1=low 6=high) in Management rating in 2013?
Provide a short and direct response. -0.29. What is the difference between the Rating (1=low 6=high) in Debt policy in 2009 and the Rating (1=low 6=high) in Management rating in 2013?
Your answer should be compact. -0.2. What is the difference between the Rating (1=low 6=high) in Building human resources in 2009 and the Rating (1=low 6=high) in Business regulatory environment in 2014?
Your response must be concise. 0.2. What is the difference between the Rating (1=low 6=high) in Building human resources in 2009 and the Rating (1=low 6=high) in Debt policy in 2014?
Make the answer very short. -0.07. What is the difference between the Rating (1=low 6=high) in Building human resources in 2009 and the Rating (1=low 6=high) in Management rating in 2014?
Keep it short and to the point. -0.06. What is the difference between the Rating (1=low 6=high) of Business regulatory environment in 2009 and the Rating (1=low 6=high) of Debt policy in 2014?
Provide a short and direct response. -0.28. What is the difference between the Rating (1=low 6=high) in Business regulatory environment in 2009 and the Rating (1=low 6=high) in Management rating in 2014?
Provide a succinct answer. -0.27. What is the difference between the Rating (1=low 6=high) in Debt policy in 2009 and the Rating (1=low 6=high) in Management rating in 2014?
Offer a terse response. -0.18. What is the difference between the Rating (1=low 6=high) in Building human resources in 2010 and the Rating (1=low 6=high) in Business regulatory environment in 2011?
Provide a short and direct response. 0.28. What is the difference between the Rating (1=low 6=high) of Building human resources in 2010 and the Rating (1=low 6=high) of Debt policy in 2011?
Give a very brief answer. 0.07. What is the difference between the Rating (1=low 6=high) of Building human resources in 2010 and the Rating (1=low 6=high) of Management rating in 2011?
Ensure brevity in your answer.  -0.09. What is the difference between the Rating (1=low 6=high) in Business regulatory environment in 2010 and the Rating (1=low 6=high) in Debt policy in 2011?
Your answer should be compact. -0.24. What is the difference between the Rating (1=low 6=high) in Business regulatory environment in 2010 and the Rating (1=low 6=high) in Management rating in 2011?
Your response must be concise. -0.39. What is the difference between the Rating (1=low 6=high) in Debt policy in 2010 and the Rating (1=low 6=high) in Management rating in 2011?
Provide a short and direct response. -0.21. What is the difference between the Rating (1=low 6=high) in Building human resources in 2010 and the Rating (1=low 6=high) in Business regulatory environment in 2012?
Your response must be concise. 0.26. What is the difference between the Rating (1=low 6=high) in Building human resources in 2010 and the Rating (1=low 6=high) in Debt policy in 2012?
Give a very brief answer. 0.06. What is the difference between the Rating (1=low 6=high) in Building human resources in 2010 and the Rating (1=low 6=high) in Management rating in 2012?
Provide a short and direct response. -0.06. What is the difference between the Rating (1=low 6=high) of Business regulatory environment in 2010 and the Rating (1=low 6=high) of Debt policy in 2012?
Your answer should be compact. -0.24. What is the difference between the Rating (1=low 6=high) of Business regulatory environment in 2010 and the Rating (1=low 6=high) of Management rating in 2012?
Make the answer very short. -0.37. What is the difference between the Rating (1=low 6=high) in Debt policy in 2010 and the Rating (1=low 6=high) in Management rating in 2012?
Make the answer very short. -0.18. What is the difference between the Rating (1=low 6=high) in Building human resources in 2010 and the Rating (1=low 6=high) in Business regulatory environment in 2013?
Offer a terse response. 0.25. What is the difference between the Rating (1=low 6=high) in Building human resources in 2010 and the Rating (1=low 6=high) in Debt policy in 2013?
Offer a very short reply. 0.03. What is the difference between the Rating (1=low 6=high) in Building human resources in 2010 and the Rating (1=low 6=high) in Management rating in 2013?
Your answer should be compact. -0.04. What is the difference between the Rating (1=low 6=high) of Business regulatory environment in 2010 and the Rating (1=low 6=high) of Debt policy in 2013?
Your answer should be very brief. -0.27. What is the difference between the Rating (1=low 6=high) in Business regulatory environment in 2010 and the Rating (1=low 6=high) in Management rating in 2013?
Offer a very short reply. -0.34. What is the difference between the Rating (1=low 6=high) of Debt policy in 2010 and the Rating (1=low 6=high) of Management rating in 2013?
Offer a very short reply. -0.16. What is the difference between the Rating (1=low 6=high) of Building human resources in 2010 and the Rating (1=low 6=high) of Business regulatory environment in 2014?
Make the answer very short. 0.24. What is the difference between the Rating (1=low 6=high) in Building human resources in 2010 and the Rating (1=low 6=high) in Debt policy in 2014?
Offer a terse response. -0.03. What is the difference between the Rating (1=low 6=high) in Building human resources in 2010 and the Rating (1=low 6=high) in Management rating in 2014?
Your answer should be compact. -0.02. What is the difference between the Rating (1=low 6=high) of Business regulatory environment in 2010 and the Rating (1=low 6=high) of Debt policy in 2014?
Provide a short and direct response. -0.33. What is the difference between the Rating (1=low 6=high) in Business regulatory environment in 2010 and the Rating (1=low 6=high) in Management rating in 2014?
Provide a short and direct response. -0.32. What is the difference between the Rating (1=low 6=high) in Debt policy in 2010 and the Rating (1=low 6=high) in Management rating in 2014?
Give a very brief answer. -0.14. What is the difference between the Rating (1=low 6=high) of Building human resources in 2011 and the Rating (1=low 6=high) of Business regulatory environment in 2012?
Your answer should be very brief. 0.38. What is the difference between the Rating (1=low 6=high) of Building human resources in 2011 and the Rating (1=low 6=high) of Debt policy in 2012?
Offer a very short reply. 0.18. What is the difference between the Rating (1=low 6=high) in Building human resources in 2011 and the Rating (1=low 6=high) in Management rating in 2012?
Make the answer very short. 0.05. What is the difference between the Rating (1=low 6=high) of Business regulatory environment in 2011 and the Rating (1=low 6=high) of Debt policy in 2012?
Make the answer very short. -0.22. What is the difference between the Rating (1=low 6=high) in Business regulatory environment in 2011 and the Rating (1=low 6=high) in Management rating in 2012?
Your answer should be compact. -0.34. What is the difference between the Rating (1=low 6=high) of Debt policy in 2011 and the Rating (1=low 6=high) of Management rating in 2012?
Offer a terse response. -0.13. What is the difference between the Rating (1=low 6=high) of Building human resources in 2011 and the Rating (1=low 6=high) of Business regulatory environment in 2013?
Offer a terse response. 0.37. What is the difference between the Rating (1=low 6=high) of Building human resources in 2011 and the Rating (1=low 6=high) of Debt policy in 2013?
Your answer should be very brief. 0.15. What is the difference between the Rating (1=low 6=high) of Building human resources in 2011 and the Rating (1=low 6=high) of Management rating in 2013?
Provide a short and direct response. 0.08. What is the difference between the Rating (1=low 6=high) in Business regulatory environment in 2011 and the Rating (1=low 6=high) in Debt policy in 2013?
Give a very brief answer. -0.24. What is the difference between the Rating (1=low 6=high) in Business regulatory environment in 2011 and the Rating (1=low 6=high) in Management rating in 2013?
Provide a succinct answer. -0.32. What is the difference between the Rating (1=low 6=high) of Debt policy in 2011 and the Rating (1=low 6=high) of Management rating in 2013?
Ensure brevity in your answer.  -0.1. What is the difference between the Rating (1=low 6=high) of Building human resources in 2011 and the Rating (1=low 6=high) of Business regulatory environment in 2014?
Your answer should be compact. 0.36. What is the difference between the Rating (1=low 6=high) in Building human resources in 2011 and the Rating (1=low 6=high) in Debt policy in 2014?
Provide a succinct answer. 0.09. What is the difference between the Rating (1=low 6=high) of Building human resources in 2011 and the Rating (1=low 6=high) of Management rating in 2014?
Provide a succinct answer. 0.1. What is the difference between the Rating (1=low 6=high) of Business regulatory environment in 2011 and the Rating (1=low 6=high) of Debt policy in 2014?
Your answer should be compact. -0.3. What is the difference between the Rating (1=low 6=high) of Business regulatory environment in 2011 and the Rating (1=low 6=high) of Management rating in 2014?
Your answer should be compact. -0.3. What is the difference between the Rating (1=low 6=high) in Debt policy in 2011 and the Rating (1=low 6=high) in Management rating in 2014?
Offer a very short reply. -0.09. What is the difference between the Rating (1=low 6=high) in Building human resources in 2012 and the Rating (1=low 6=high) in Business regulatory environment in 2013?
Offer a very short reply. 0.4. What is the difference between the Rating (1=low 6=high) in Building human resources in 2012 and the Rating (1=low 6=high) in Debt policy in 2013?
Give a very brief answer. 0.18. What is the difference between the Rating (1=low 6=high) of Building human resources in 2012 and the Rating (1=low 6=high) of Management rating in 2013?
Provide a succinct answer. 0.11. What is the difference between the Rating (1=low 6=high) in Business regulatory environment in 2012 and the Rating (1=low 6=high) in Debt policy in 2013?
Give a very brief answer. -0.23. What is the difference between the Rating (1=low 6=high) of Business regulatory environment in 2012 and the Rating (1=low 6=high) of Management rating in 2013?
Keep it short and to the point. -0.3. What is the difference between the Rating (1=low 6=high) of Debt policy in 2012 and the Rating (1=low 6=high) of Management rating in 2013?
Make the answer very short. -0.1. What is the difference between the Rating (1=low 6=high) of Building human resources in 2012 and the Rating (1=low 6=high) of Business regulatory environment in 2014?
Make the answer very short. 0.38. What is the difference between the Rating (1=low 6=high) of Building human resources in 2012 and the Rating (1=low 6=high) of Debt policy in 2014?
Ensure brevity in your answer.  0.12. What is the difference between the Rating (1=low 6=high) of Building human resources in 2012 and the Rating (1=low 6=high) of Management rating in 2014?
Your answer should be very brief. 0.12. What is the difference between the Rating (1=low 6=high) of Business regulatory environment in 2012 and the Rating (1=low 6=high) of Debt policy in 2014?
Provide a short and direct response. -0.29. What is the difference between the Rating (1=low 6=high) of Business regulatory environment in 2012 and the Rating (1=low 6=high) of Management rating in 2014?
Your response must be concise. -0.29. What is the difference between the Rating (1=low 6=high) in Debt policy in 2012 and the Rating (1=low 6=high) in Management rating in 2014?
Make the answer very short. -0.08. What is the difference between the Rating (1=low 6=high) in Building human resources in 2013 and the Rating (1=low 6=high) in Business regulatory environment in 2014?
Give a very brief answer. 0.41. What is the difference between the Rating (1=low 6=high) in Building human resources in 2013 and the Rating (1=low 6=high) in Debt policy in 2014?
Provide a succinct answer. 0.15. What is the difference between the Rating (1=low 6=high) of Building human resources in 2013 and the Rating (1=low 6=high) of Management rating in 2014?
Offer a terse response. 0.15. What is the difference between the Rating (1=low 6=high) of Business regulatory environment in 2013 and the Rating (1=low 6=high) of Debt policy in 2014?
Your answer should be compact. -0.28. What is the difference between the Rating (1=low 6=high) of Business regulatory environment in 2013 and the Rating (1=low 6=high) of Management rating in 2014?
Give a very brief answer. -0.27. What is the difference between the Rating (1=low 6=high) in Debt policy in 2013 and the Rating (1=low 6=high) in Management rating in 2014?
Your answer should be compact. -0.06. What is the average Rating (1=low 6=high) in Building human resources per year?
Keep it short and to the point. 3.36. What is the average Rating (1=low 6=high) in Business regulatory environment per year?
Provide a short and direct response. 3.05. What is the average Rating (1=low 6=high) in Debt policy per year?
Ensure brevity in your answer.  3.2. What is the average Rating (1=low 6=high) of Management rating per year?
Your response must be concise. 3.36. In the year 2006, what is the difference between the Rating (1=low 6=high) of Building human resources and Rating (1=low 6=high) of Business regulatory environment?
Offer a very short reply. 0.16. In the year 2006, what is the difference between the Rating (1=low 6=high) of Building human resources and Rating (1=low 6=high) of Debt policy?
Your response must be concise. 0.22. In the year 2006, what is the difference between the Rating (1=low 6=high) in Building human resources and Rating (1=low 6=high) in Management rating?
Make the answer very short. -0.08. In the year 2006, what is the difference between the Rating (1=low 6=high) in Business regulatory environment and Rating (1=low 6=high) in Debt policy?
Your answer should be very brief. 0.05. In the year 2006, what is the difference between the Rating (1=low 6=high) of Business regulatory environment and Rating (1=low 6=high) of Management rating?
Your answer should be compact. -0.24. In the year 2006, what is the difference between the Rating (1=low 6=high) of Debt policy and Rating (1=low 6=high) of Management rating?
Your answer should be compact. -0.29. In the year 2007, what is the difference between the Rating (1=low 6=high) of Building human resources and Rating (1=low 6=high) of Business regulatory environment?
Offer a very short reply. 0.19. In the year 2007, what is the difference between the Rating (1=low 6=high) of Building human resources and Rating (1=low 6=high) of Debt policy?
Your response must be concise. 0.14. In the year 2007, what is the difference between the Rating (1=low 6=high) in Building human resources and Rating (1=low 6=high) in Management rating?
Offer a very short reply. -0.1. In the year 2007, what is the difference between the Rating (1=low 6=high) in Business regulatory environment and Rating (1=low 6=high) in Debt policy?
Ensure brevity in your answer.  -0.05. In the year 2007, what is the difference between the Rating (1=low 6=high) in Business regulatory environment and Rating (1=low 6=high) in Management rating?
Keep it short and to the point. -0.29. In the year 2007, what is the difference between the Rating (1=low 6=high) in Debt policy and Rating (1=low 6=high) in Management rating?
Provide a succinct answer. -0.23. In the year 2008, what is the difference between the Rating (1=low 6=high) in Building human resources and Rating (1=low 6=high) in Business regulatory environment?
Ensure brevity in your answer.  0.2. In the year 2008, what is the difference between the Rating (1=low 6=high) in Building human resources and Rating (1=low 6=high) in Debt policy?
Give a very brief answer. 0.08. In the year 2008, what is the difference between the Rating (1=low 6=high) in Building human resources and Rating (1=low 6=high) in Management rating?
Give a very brief answer. -0.11. In the year 2008, what is the difference between the Rating (1=low 6=high) of Business regulatory environment and Rating (1=low 6=high) of Debt policy?
Keep it short and to the point. -0.12. In the year 2008, what is the difference between the Rating (1=low 6=high) in Business regulatory environment and Rating (1=low 6=high) in Management rating?
Offer a terse response. -0.31. In the year 2008, what is the difference between the Rating (1=low 6=high) of Debt policy and Rating (1=low 6=high) of Management rating?
Ensure brevity in your answer.  -0.19. In the year 2009, what is the difference between the Rating (1=low 6=high) of Building human resources and Rating (1=low 6=high) of Business regulatory environment?
Ensure brevity in your answer.  0.21. In the year 2009, what is the difference between the Rating (1=low 6=high) in Building human resources and Rating (1=low 6=high) in Debt policy?
Keep it short and to the point. 0.12. In the year 2009, what is the difference between the Rating (1=low 6=high) of Building human resources and Rating (1=low 6=high) of Management rating?
Keep it short and to the point. -0.11. In the year 2009, what is the difference between the Rating (1=low 6=high) in Business regulatory environment and Rating (1=low 6=high) in Debt policy?
Offer a terse response. -0.09. In the year 2009, what is the difference between the Rating (1=low 6=high) of Business regulatory environment and Rating (1=low 6=high) of Management rating?
Offer a terse response. -0.32. In the year 2009, what is the difference between the Rating (1=low 6=high) of Debt policy and Rating (1=low 6=high) of Management rating?
Offer a very short reply. -0.23. In the year 2010, what is the difference between the Rating (1=low 6=high) of Building human resources and Rating (1=low 6=high) of Business regulatory environment?
Offer a terse response. 0.3. In the year 2010, what is the difference between the Rating (1=low 6=high) of Building human resources and Rating (1=low 6=high) of Debt policy?
Offer a very short reply. 0.12. In the year 2010, what is the difference between the Rating (1=low 6=high) in Building human resources and Rating (1=low 6=high) in Management rating?
Make the answer very short. -0.07. In the year 2010, what is the difference between the Rating (1=low 6=high) in Business regulatory environment and Rating (1=low 6=high) in Debt policy?
Your answer should be compact. -0.18. In the year 2010, what is the difference between the Rating (1=low 6=high) in Business regulatory environment and Rating (1=low 6=high) in Management rating?
Give a very brief answer. -0.37. In the year 2010, what is the difference between the Rating (1=low 6=high) in Debt policy and Rating (1=low 6=high) in Management rating?
Make the answer very short. -0.18. In the year 2011, what is the difference between the Rating (1=low 6=high) in Building human resources and Rating (1=low 6=high) in Business regulatory environment?
Offer a terse response. 0.39. In the year 2011, what is the difference between the Rating (1=low 6=high) in Building human resources and Rating (1=low 6=high) in Debt policy?
Keep it short and to the point. 0.18. In the year 2011, what is the difference between the Rating (1=low 6=high) of Building human resources and Rating (1=low 6=high) of Management rating?
Provide a succinct answer. 0.03. In the year 2011, what is the difference between the Rating (1=low 6=high) of Business regulatory environment and Rating (1=low 6=high) of Debt policy?
Ensure brevity in your answer.  -0.21. In the year 2011, what is the difference between the Rating (1=low 6=high) in Business regulatory environment and Rating (1=low 6=high) in Management rating?
Your answer should be compact. -0.36. In the year 2011, what is the difference between the Rating (1=low 6=high) of Debt policy and Rating (1=low 6=high) of Management rating?
Keep it short and to the point. -0.15. In the year 2012, what is the difference between the Rating (1=low 6=high) in Building human resources and Rating (1=low 6=high) in Business regulatory environment?
Make the answer very short. 0.41. In the year 2012, what is the difference between the Rating (1=low 6=high) of Building human resources and Rating (1=low 6=high) of Debt policy?
Keep it short and to the point. 0.21. In the year 2012, what is the difference between the Rating (1=low 6=high) in Building human resources and Rating (1=low 6=high) in Management rating?
Your answer should be very brief. 0.08. In the year 2012, what is the difference between the Rating (1=low 6=high) in Business regulatory environment and Rating (1=low 6=high) in Debt policy?
Your answer should be compact. -0.21. In the year 2012, what is the difference between the Rating (1=low 6=high) of Business regulatory environment and Rating (1=low 6=high) of Management rating?
Give a very brief answer. -0.33. In the year 2012, what is the difference between the Rating (1=low 6=high) in Debt policy and Rating (1=low 6=high) in Management rating?
Your answer should be very brief. -0.12. In the year 2013, what is the difference between the Rating (1=low 6=high) of Building human resources and Rating (1=low 6=high) of Business regulatory environment?
Your answer should be compact. 0.42. In the year 2013, what is the difference between the Rating (1=low 6=high) in Building human resources and Rating (1=low 6=high) in Debt policy?
Offer a terse response. 0.21. In the year 2013, what is the difference between the Rating (1=low 6=high) in Building human resources and Rating (1=low 6=high) in Management rating?
Offer a very short reply. 0.13. In the year 2013, what is the difference between the Rating (1=low 6=high) in Business regulatory environment and Rating (1=low 6=high) in Debt policy?
Ensure brevity in your answer.  -0.22. In the year 2013, what is the difference between the Rating (1=low 6=high) of Business regulatory environment and Rating (1=low 6=high) of Management rating?
Provide a succinct answer. -0.29. In the year 2013, what is the difference between the Rating (1=low 6=high) of Debt policy and Rating (1=low 6=high) of Management rating?
Give a very brief answer. -0.07. In the year 2014, what is the difference between the Rating (1=low 6=high) of Building human resources and Rating (1=low 6=high) of Business regulatory environment?
Your answer should be compact. 0.45. In the year 2014, what is the difference between the Rating (1=low 6=high) of Building human resources and Rating (1=low 6=high) of Debt policy?
Provide a succinct answer. 0.18. In the year 2014, what is the difference between the Rating (1=low 6=high) in Building human resources and Rating (1=low 6=high) in Management rating?
Provide a succinct answer. 0.19. In the year 2014, what is the difference between the Rating (1=low 6=high) of Business regulatory environment and Rating (1=low 6=high) of Debt policy?
Offer a very short reply. -0.26. In the year 2014, what is the difference between the Rating (1=low 6=high) in Business regulatory environment and Rating (1=low 6=high) in Management rating?
Offer a very short reply. -0.26. In the year 2014, what is the difference between the Rating (1=low 6=high) of Debt policy and Rating (1=low 6=high) of Management rating?
Give a very brief answer. 0. What is the ratio of the Rating (1=low 6=high) in Building human resources in 2006 to that in 2007?
Provide a succinct answer. 0.99. What is the ratio of the Rating (1=low 6=high) in Debt policy in 2006 to that in 2007?
Give a very brief answer. 0.96. What is the ratio of the Rating (1=low 6=high) of Management rating in 2006 to that in 2007?
Offer a terse response. 0.98. What is the ratio of the Rating (1=low 6=high) of Building human resources in 2006 to that in 2008?
Keep it short and to the point. 0.99. What is the ratio of the Rating (1=low 6=high) of Business regulatory environment in 2006 to that in 2008?
Your answer should be very brief. 1. What is the ratio of the Rating (1=low 6=high) in Debt policy in 2006 to that in 2008?
Make the answer very short. 0.94. What is the ratio of the Rating (1=low 6=high) in Management rating in 2006 to that in 2008?
Your response must be concise. 0.98. What is the ratio of the Rating (1=low 6=high) of Building human resources in 2006 to that in 2009?
Offer a very short reply. 0.98. What is the ratio of the Rating (1=low 6=high) in Business regulatory environment in 2006 to that in 2009?
Your response must be concise. 1. What is the ratio of the Rating (1=low 6=high) in Management rating in 2006 to that in 2009?
Give a very brief answer. 0.97. What is the ratio of the Rating (1=low 6=high) of Building human resources in 2006 to that in 2010?
Your answer should be very brief. 0.97. What is the ratio of the Rating (1=low 6=high) in Business regulatory environment in 2006 to that in 2010?
Offer a very short reply. 1.01. What is the ratio of the Rating (1=low 6=high) of Debt policy in 2006 to that in 2010?
Provide a succinct answer. 0.94. What is the ratio of the Rating (1=low 6=high) of Management rating in 2006 to that in 2010?
Make the answer very short. 0.97. What is the ratio of the Rating (1=low 6=high) in Building human resources in 2006 to that in 2011?
Your response must be concise. 0.94. What is the ratio of the Rating (1=low 6=high) in Management rating in 2006 to that in 2011?
Give a very brief answer. 0.97. What is the ratio of the Rating (1=low 6=high) of Building human resources in 2006 to that in 2012?
Offer a very short reply. 0.93. What is the ratio of the Rating (1=low 6=high) of Business regulatory environment in 2006 to that in 2012?
Provide a succinct answer. 1. What is the ratio of the Rating (1=low 6=high) in Debt policy in 2006 to that in 2012?
Offer a very short reply. 0.92. What is the ratio of the Rating (1=low 6=high) of Management rating in 2006 to that in 2012?
Give a very brief answer. 0.97. What is the ratio of the Rating (1=low 6=high) of Building human resources in 2006 to that in 2013?
Give a very brief answer. 0.92. What is the ratio of the Rating (1=low 6=high) of Business regulatory environment in 2006 to that in 2013?
Offer a very short reply. 1. What is the ratio of the Rating (1=low 6=high) of Debt policy in 2006 to that in 2013?
Offer a very short reply. 0.91. What is the ratio of the Rating (1=low 6=high) of Management rating in 2006 to that in 2013?
Give a very brief answer. 0.98. What is the ratio of the Rating (1=low 6=high) in Building human resources in 2006 to that in 2014?
Offer a very short reply. 0.91. What is the ratio of the Rating (1=low 6=high) in Business regulatory environment in 2006 to that in 2014?
Your response must be concise. 0.99. What is the ratio of the Rating (1=low 6=high) in Debt policy in 2006 to that in 2014?
Keep it short and to the point. 0.9. What is the ratio of the Rating (1=low 6=high) of Management rating in 2006 to that in 2014?
Offer a terse response. 0.99. What is the ratio of the Rating (1=low 6=high) in Building human resources in 2007 to that in 2008?
Your answer should be very brief. 1. What is the ratio of the Rating (1=low 6=high) in Business regulatory environment in 2007 to that in 2008?
Your response must be concise. 1. What is the ratio of the Rating (1=low 6=high) of Management rating in 2007 to that in 2008?
Ensure brevity in your answer.  1. What is the ratio of the Rating (1=low 6=high) in Business regulatory environment in 2007 to that in 2009?
Your response must be concise. 1. What is the ratio of the Rating (1=low 6=high) of Management rating in 2007 to that in 2009?
Provide a short and direct response. 0.99. What is the ratio of the Rating (1=low 6=high) in Building human resources in 2007 to that in 2010?
Provide a succinct answer. 0.98. What is the ratio of the Rating (1=low 6=high) in Business regulatory environment in 2007 to that in 2010?
Your answer should be very brief. 1.02. What is the ratio of the Rating (1=low 6=high) of Debt policy in 2007 to that in 2010?
Your answer should be compact. 0.98. What is the ratio of the Rating (1=low 6=high) of Building human resources in 2007 to that in 2011?
Your answer should be compact. 0.95. What is the ratio of the Rating (1=low 6=high) of Business regulatory environment in 2007 to that in 2011?
Keep it short and to the point. 1.01. What is the ratio of the Rating (1=low 6=high) of Debt policy in 2007 to that in 2011?
Provide a short and direct response. 0.96. What is the ratio of the Rating (1=low 6=high) of Building human resources in 2007 to that in 2012?
Offer a terse response. 0.94. What is the ratio of the Rating (1=low 6=high) in Business regulatory environment in 2007 to that in 2012?
Your response must be concise. 1.01. What is the ratio of the Rating (1=low 6=high) of Debt policy in 2007 to that in 2012?
Keep it short and to the point. 0.96. What is the ratio of the Rating (1=low 6=high) in Building human resources in 2007 to that in 2013?
Your answer should be very brief. 0.93. What is the ratio of the Rating (1=low 6=high) in Business regulatory environment in 2007 to that in 2013?
Ensure brevity in your answer.  1. What is the ratio of the Rating (1=low 6=high) in Debt policy in 2007 to that in 2013?
Make the answer very short. 0.95. What is the ratio of the Rating (1=low 6=high) in Management rating in 2007 to that in 2013?
Keep it short and to the point. 1. What is the ratio of the Rating (1=low 6=high) of Building human resources in 2007 to that in 2014?
Make the answer very short. 0.92. What is the ratio of the Rating (1=low 6=high) of Debt policy in 2007 to that in 2014?
Ensure brevity in your answer.  0.93. What is the ratio of the Rating (1=low 6=high) in Management rating in 2007 to that in 2014?
Provide a succinct answer. 1.01. What is the ratio of the Rating (1=low 6=high) in Business regulatory environment in 2008 to that in 2009?
Ensure brevity in your answer.  1. What is the ratio of the Rating (1=low 6=high) of Debt policy in 2008 to that in 2009?
Offer a very short reply. 1.01. What is the ratio of the Rating (1=low 6=high) in Management rating in 2008 to that in 2009?
Keep it short and to the point. 0.99. What is the ratio of the Rating (1=low 6=high) in Building human resources in 2008 to that in 2010?
Give a very brief answer. 0.98. What is the ratio of the Rating (1=low 6=high) of Business regulatory environment in 2008 to that in 2010?
Ensure brevity in your answer.  1.01. What is the ratio of the Rating (1=low 6=high) in Management rating in 2008 to that in 2010?
Make the answer very short. 1. What is the ratio of the Rating (1=low 6=high) in Building human resources in 2008 to that in 2011?
Offer a terse response. 0.95. What is the ratio of the Rating (1=low 6=high) in Business regulatory environment in 2008 to that in 2011?
Provide a succinct answer. 1. What is the ratio of the Rating (1=low 6=high) in Debt policy in 2008 to that in 2011?
Make the answer very short. 0.98. What is the ratio of the Rating (1=low 6=high) in Management rating in 2008 to that in 2011?
Make the answer very short. 0.99. What is the ratio of the Rating (1=low 6=high) in Building human resources in 2008 to that in 2012?
Ensure brevity in your answer.  0.94. What is the ratio of the Rating (1=low 6=high) of Debt policy in 2008 to that in 2012?
Your answer should be compact. 0.98. What is the ratio of the Rating (1=low 6=high) of Building human resources in 2008 to that in 2013?
Provide a short and direct response. 0.93. What is the ratio of the Rating (1=low 6=high) in Business regulatory environment in 2008 to that in 2013?
Offer a terse response. 1. What is the ratio of the Rating (1=low 6=high) of Debt policy in 2008 to that in 2013?
Your answer should be compact. 0.97. What is the ratio of the Rating (1=low 6=high) in Building human resources in 2008 to that in 2014?
Provide a succinct answer. 0.92. What is the ratio of the Rating (1=low 6=high) in Business regulatory environment in 2008 to that in 2014?
Offer a very short reply. 0.99. What is the ratio of the Rating (1=low 6=high) of Debt policy in 2008 to that in 2014?
Your response must be concise. 0.95. What is the ratio of the Rating (1=low 6=high) of Building human resources in 2009 to that in 2010?
Offer a terse response. 0.99. What is the ratio of the Rating (1=low 6=high) in Business regulatory environment in 2009 to that in 2010?
Give a very brief answer. 1.02. What is the ratio of the Rating (1=low 6=high) of Management rating in 2009 to that in 2010?
Offer a terse response. 1. What is the ratio of the Rating (1=low 6=high) in Building human resources in 2009 to that in 2011?
Make the answer very short. 0.95. What is the ratio of the Rating (1=low 6=high) of Business regulatory environment in 2009 to that in 2011?
Make the answer very short. 1.01. What is the ratio of the Rating (1=low 6=high) of Debt policy in 2009 to that in 2011?
Keep it short and to the point. 0.97. What is the ratio of the Rating (1=low 6=high) in Management rating in 2009 to that in 2011?
Your answer should be very brief. 0.99. What is the ratio of the Rating (1=low 6=high) of Building human resources in 2009 to that in 2012?
Provide a short and direct response. 0.95. What is the ratio of the Rating (1=low 6=high) in Debt policy in 2009 to that in 2012?
Provide a succinct answer. 0.97. What is the ratio of the Rating (1=low 6=high) of Building human resources in 2009 to that in 2013?
Make the answer very short. 0.94. What is the ratio of the Rating (1=low 6=high) in Debt policy in 2009 to that in 2013?
Provide a succinct answer. 0.96. What is the ratio of the Rating (1=low 6=high) of Management rating in 2009 to that in 2013?
Your answer should be compact. 1.01. What is the ratio of the Rating (1=low 6=high) in Building human resources in 2009 to that in 2014?
Make the answer very short. 0.93. What is the ratio of the Rating (1=low 6=high) in Debt policy in 2009 to that in 2014?
Your answer should be very brief. 0.94. What is the ratio of the Rating (1=low 6=high) in Management rating in 2009 to that in 2014?
Offer a terse response. 1.01. What is the ratio of the Rating (1=low 6=high) of Building human resources in 2010 to that in 2011?
Offer a terse response. 0.97. What is the ratio of the Rating (1=low 6=high) of Debt policy in 2010 to that in 2011?
Give a very brief answer. 0.98. What is the ratio of the Rating (1=low 6=high) in Building human resources in 2010 to that in 2012?
Your answer should be compact. 0.96. What is the ratio of the Rating (1=low 6=high) of Business regulatory environment in 2010 to that in 2012?
Offer a terse response. 0.99. What is the ratio of the Rating (1=low 6=high) of Debt policy in 2010 to that in 2012?
Offer a terse response. 0.98. What is the ratio of the Rating (1=low 6=high) of Building human resources in 2010 to that in 2013?
Keep it short and to the point. 0.95. What is the ratio of the Rating (1=low 6=high) in Business regulatory environment in 2010 to that in 2013?
Keep it short and to the point. 0.98. What is the ratio of the Rating (1=low 6=high) of Debt policy in 2010 to that in 2013?
Provide a short and direct response. 0.97. What is the ratio of the Rating (1=low 6=high) of Management rating in 2010 to that in 2013?
Keep it short and to the point. 1.01. What is the ratio of the Rating (1=low 6=high) of Building human resources in 2010 to that in 2014?
Ensure brevity in your answer.  0.94. What is the ratio of the Rating (1=low 6=high) in Business regulatory environment in 2010 to that in 2014?
Offer a terse response. 0.98. What is the ratio of the Rating (1=low 6=high) in Debt policy in 2010 to that in 2014?
Keep it short and to the point. 0.96. What is the ratio of the Rating (1=low 6=high) in Management rating in 2010 to that in 2014?
Ensure brevity in your answer.  1.01. What is the ratio of the Rating (1=low 6=high) in Management rating in 2011 to that in 2012?
Your answer should be very brief. 1.01. What is the ratio of the Rating (1=low 6=high) in Debt policy in 2011 to that in 2013?
Your response must be concise. 0.99. What is the ratio of the Rating (1=low 6=high) in Management rating in 2011 to that in 2013?
Offer a very short reply. 1.01. What is the ratio of the Rating (1=low 6=high) of Building human resources in 2011 to that in 2014?
Offer a terse response. 0.97. What is the ratio of the Rating (1=low 6=high) of Business regulatory environment in 2011 to that in 2014?
Ensure brevity in your answer.  0.99. What is the ratio of the Rating (1=low 6=high) of Debt policy in 2011 to that in 2014?
Give a very brief answer. 0.97. What is the ratio of the Rating (1=low 6=high) in Management rating in 2011 to that in 2014?
Provide a short and direct response. 1.02. What is the ratio of the Rating (1=low 6=high) of Building human resources in 2012 to that in 2013?
Provide a succinct answer. 0.99. What is the ratio of the Rating (1=low 6=high) of Business regulatory environment in 2012 to that in 2013?
Give a very brief answer. 1. What is the ratio of the Rating (1=low 6=high) of Debt policy in 2012 to that in 2013?
Provide a succinct answer. 0.99. What is the ratio of the Rating (1=low 6=high) of Management rating in 2012 to that in 2013?
Keep it short and to the point. 1.01. What is the ratio of the Rating (1=low 6=high) in Building human resources in 2012 to that in 2014?
Keep it short and to the point. 0.98. What is the ratio of the Rating (1=low 6=high) in Debt policy in 2012 to that in 2014?
Keep it short and to the point. 0.97. What is the ratio of the Rating (1=low 6=high) in Management rating in 2012 to that in 2014?
Offer a terse response. 1.01. What is the ratio of the Rating (1=low 6=high) of Building human resources in 2013 to that in 2014?
Offer a terse response. 0.99. What is the ratio of the Rating (1=low 6=high) of Management rating in 2013 to that in 2014?
Ensure brevity in your answer.  1.01. What is the difference between the highest and the second highest Rating (1=low 6=high) of Building human resources?
Your answer should be compact. 0.04. What is the difference between the highest and the second highest Rating (1=low 6=high) of Business regulatory environment?
Give a very brief answer. 0.01. What is the difference between the highest and the second highest Rating (1=low 6=high) of Debt policy?
Keep it short and to the point. 0.06. What is the difference between the highest and the second highest Rating (1=low 6=high) in Management rating?
Offer a terse response. 0.02. What is the difference between the highest and the lowest Rating (1=low 6=high) in Building human resources?
Provide a succinct answer. 0.31. What is the difference between the highest and the lowest Rating (1=low 6=high) of Business regulatory environment?
Give a very brief answer. 0.07. What is the difference between the highest and the lowest Rating (1=low 6=high) in Debt policy?
Provide a short and direct response. 0.34. What is the difference between the highest and the lowest Rating (1=low 6=high) of Management rating?
Provide a succinct answer. 0.11. 